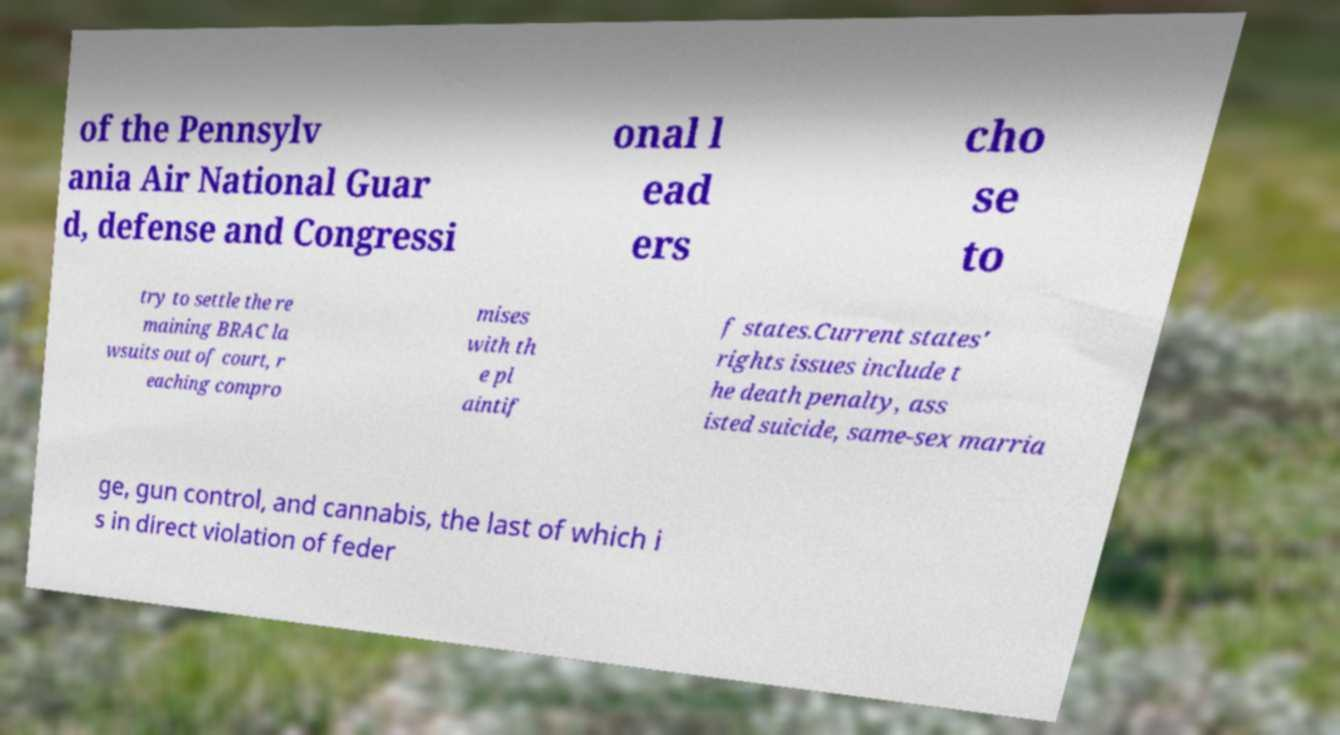Can you read and provide the text displayed in the image?This photo seems to have some interesting text. Can you extract and type it out for me? of the Pennsylv ania Air National Guar d, defense and Congressi onal l ead ers cho se to try to settle the re maining BRAC la wsuits out of court, r eaching compro mises with th e pl aintif f states.Current states' rights issues include t he death penalty, ass isted suicide, same-sex marria ge, gun control, and cannabis, the last of which i s in direct violation of feder 